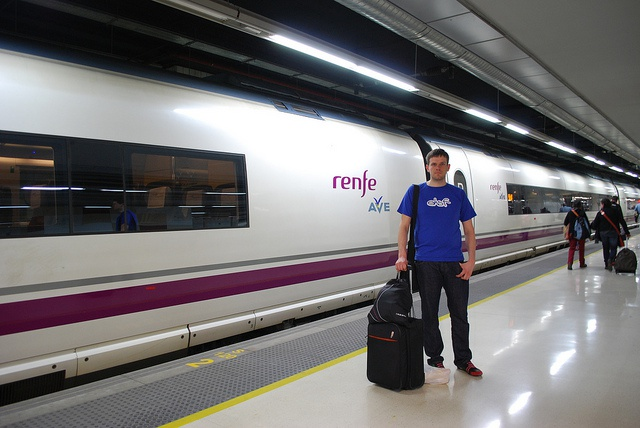Describe the objects in this image and their specific colors. I can see train in black, darkgray, lightgray, and gray tones, people in black, navy, brown, and darkblue tones, suitcase in black, gray, darkgray, and maroon tones, handbag in black and gray tones, and people in black and navy tones in this image. 